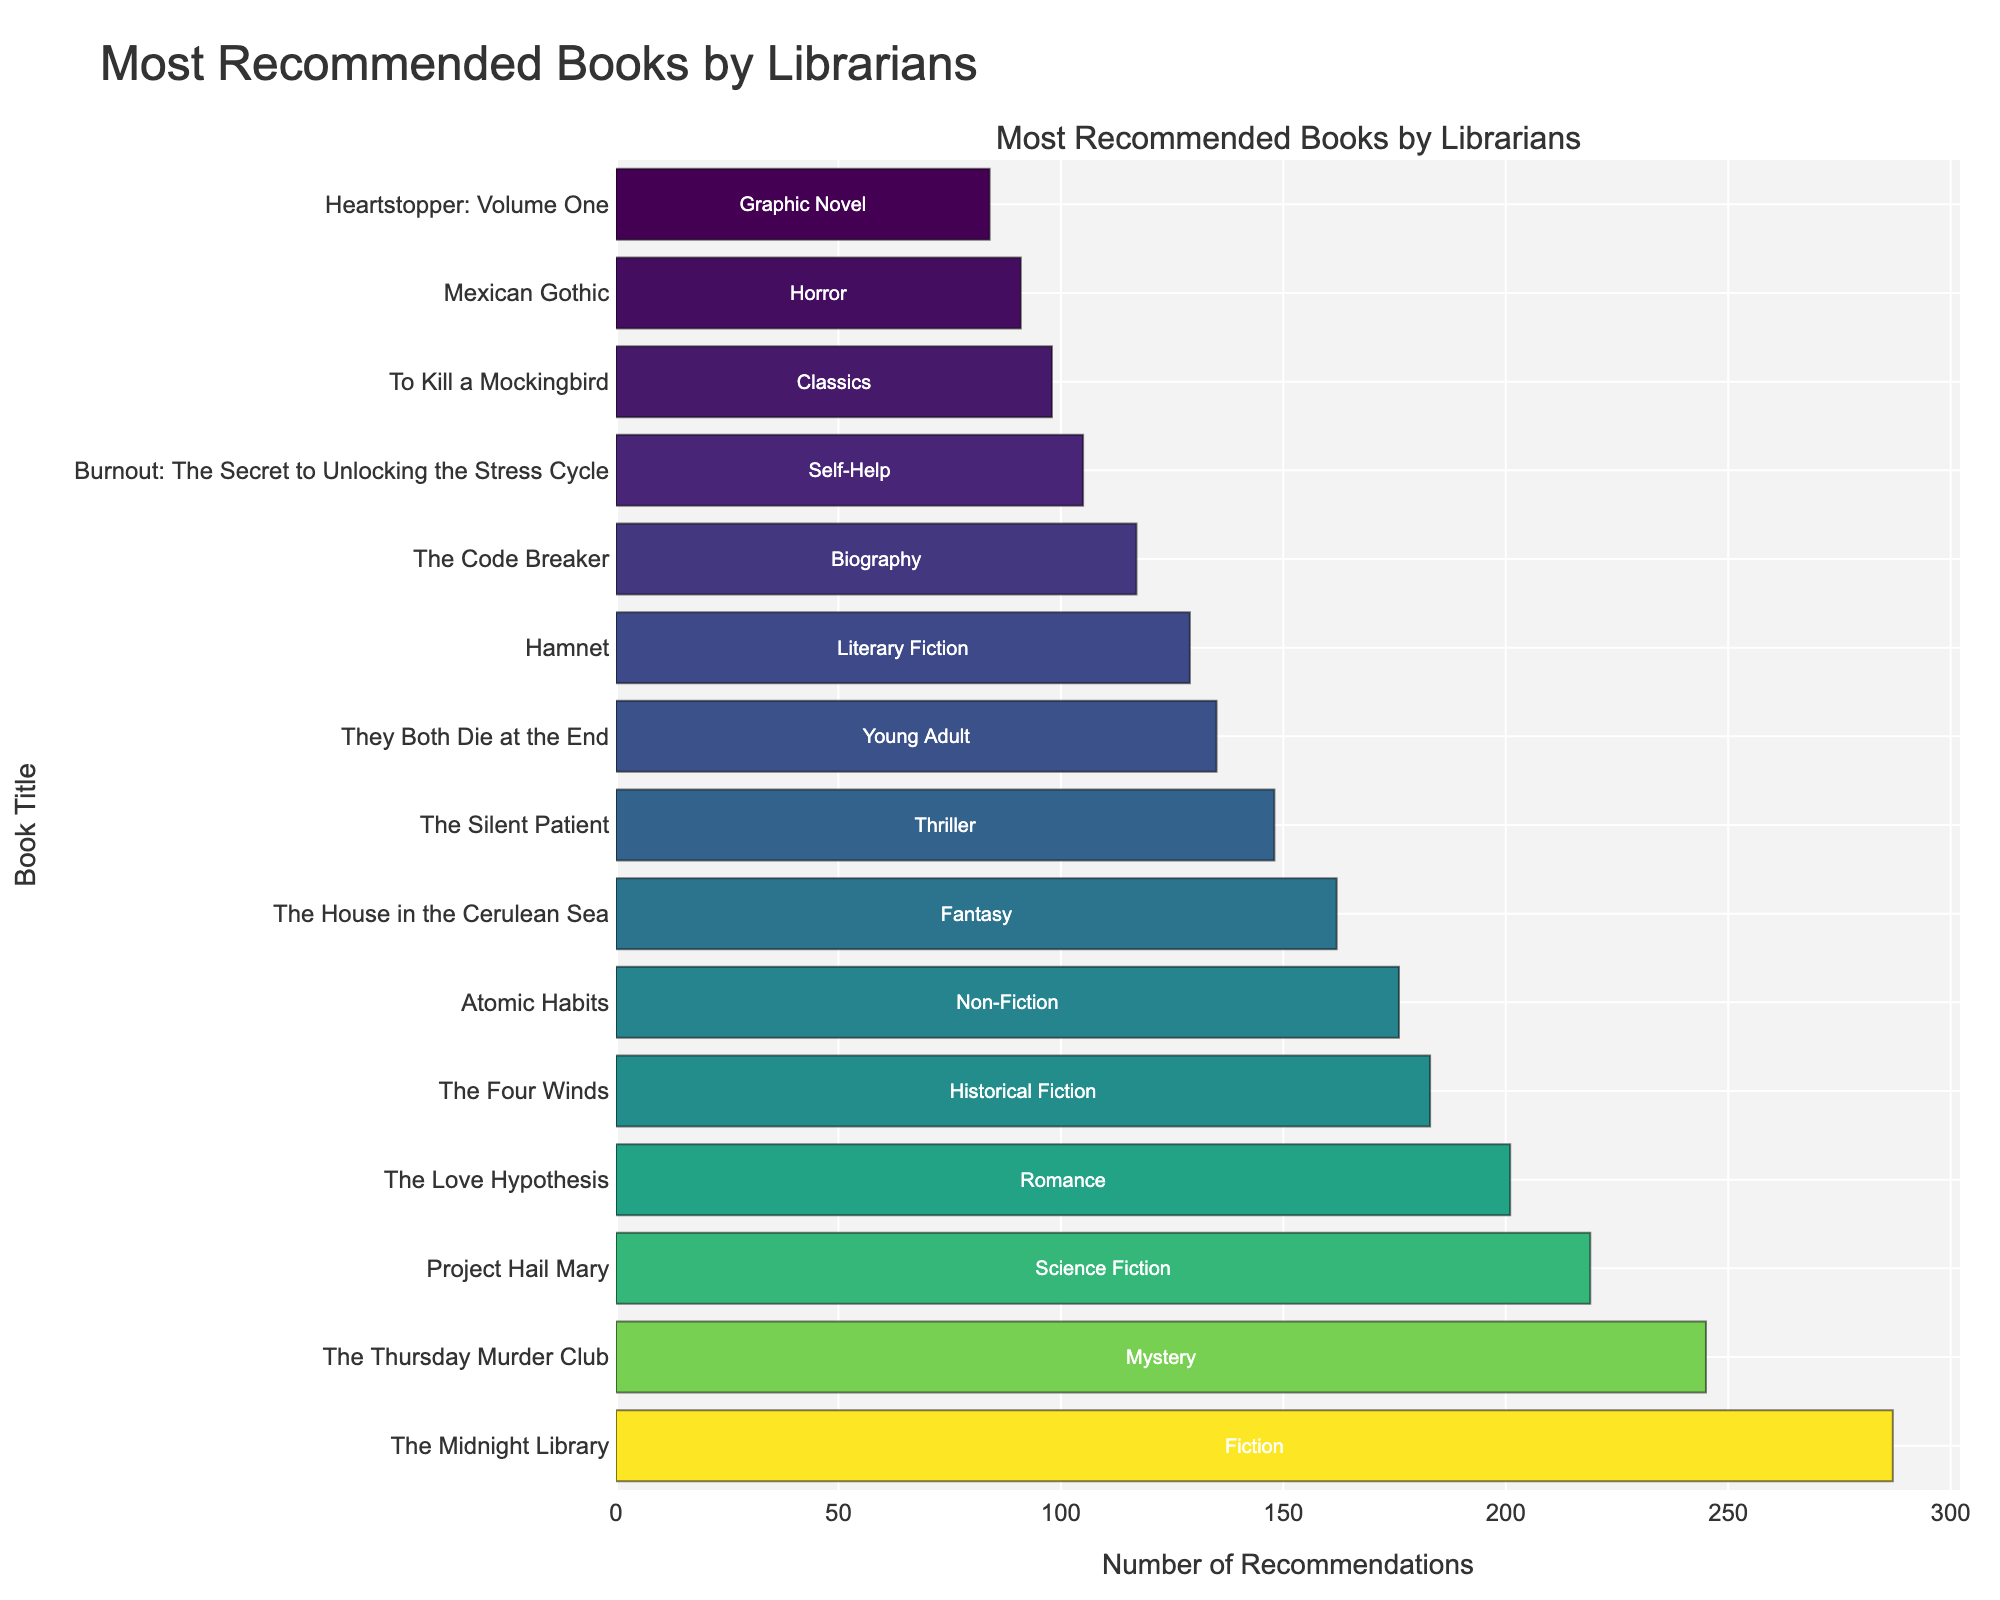Which book received the most recommendations? By observing the length of the bars, the book at the top with the longest bar is "The Midnight Library". The figure shows that this book received the highest number of recommendations: 287.
Answer: The Midnight Library Which genre is "Hamnet" classified under and how many recommendations did it receive? The hover information for "Hamnet" displays that it falls under the Literary Fiction genre and received 129 recommendations.
Answer: Literary Fiction, 129 How many more recommendations did "The Midnight Library" receive compared to "The Love Hypothesis"? "The Midnight Library" received 287 recommendations, and "The Love Hypothesis" received 201. Subtracting these values gives 287 - 201 = 86.
Answer: 86 What are the total recommendations for the top two books? The top two books are "The Midnight Library" with 287 recommendations and "The Thursday Murder Club" with 245. Adding these values gives 287 + 245 = 532.
Answer: 532 Which book received the least recommendations, and under what genre is it? The shortest bar and the last entry on the bar chart represents "Heartstopper: Volume One" with 84 recommendations. It falls under the Graphic Novel genre.
Answer: Heartstopper: Volume One, Graphic Novel What is the difference in recommendations between "Atomic Habits" and "The Silent Patient"? "Atomic Habits" has 176 recommendations, and "The Silent Patient" has 148. Subtracting these values gives 176 - 148 = 28.
Answer: 28 How many recommendations do the books under the categories of Fiction, Mystery, and Science Fiction receive in total? Summing the recommendations for "The Midnight Library" (Fiction) 287, "The Thursday Murder Club" (Mystery) 245, and "Project Hail Mary" (Science Fiction) 219, we get 287 + 245 + 219 = 751.
Answer: 751 Which book has almost the same number of recommendations as "Burnout: The Secret to Unlocking the Stress Cycle"? "To Kill a Mockingbird" has 98 recommendations, while "Burnout: The Secret to Unlocking the Stress Cycle" has 105. The difference is 105 - 98 = 7, making them roughly close.
Answer: To Kill a Mockingbird What is the combined number of recommendations for "They Both Die at the End" and "Hamnet"? "They Both Die at the End" has 135 recommendations and "Hamnet" has 129 recommendations. Adding these values gives 135 + 129 = 264.
Answer: 264 What visual feature does the plot use to distinguish between different recommendation counts? The bars are colored using a gradient from a colorscale. Darker and more vibrant bars indicate a higher count of recommendations, as seen in the visually longest bars.
Answer: Gradient colors 